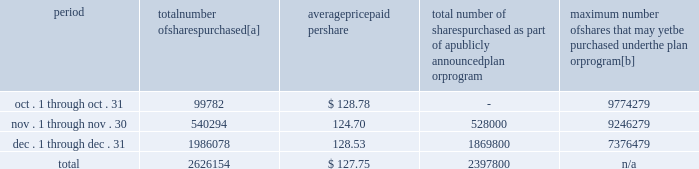Five-year performance comparison 2013 the following graph provides an indicator of cumulative total shareholder returns for the corporation as compared to the peer group index ( described above ) , the dow jones , and the s&p 500 .
The graph assumes that the value of the investment in the common stock of union pacific corporation and each index was $ 100 on december 31 , 2002 , and that all dividends were reinvested .
Comparison of five-year cumulative return 2002 2003 2004 2005 2006 2007 upc s&p 500 peer group dj trans purchases of equity securities 2013 during 2007 , we repurchased 13266070 shares of our common stock at an average price of $ 115.66 .
During the first nine months of 2007 , we repurchased 10639916 shares of our common stock at an average price per share of $ 112.68 .
The table presents common stock repurchases during each month for the fourth quarter of 2007 : period number of shares purchased average paid per total number of shares purchased as part of a publicly announced plan or program maximum number of shares that may yet be purchased under the plan or program .
[a] total number of shares purchased during the quarter includes 228354 shares delivered or attested to upc by employees to pay stock option exercise prices , satisfy excess tax withholding obligations for stock option exercises or vesting of retention units , and pay withholding obligations for vesting of retention shares .
[b] on january 30 , 2007 , our board of directors authorized us to repurchase up to 20 million shares of our common stock through december 31 , 2009 .
We may make these repurchases on the open market or through other transactions .
Our management has sole discretion with respect to determining the timing and amount of these transactions. .
What the percent of the total number of shares purchased in the fourth quarter of 2007 that was attested to upc by employees to pay stock option exercise prices? 
Computations: (228354 / 2626154)
Answer: 0.08695. Five-year performance comparison 2013 the following graph provides an indicator of cumulative total shareholder returns for the corporation as compared to the peer group index ( described above ) , the dow jones , and the s&p 500 .
The graph assumes that the value of the investment in the common stock of union pacific corporation and each index was $ 100 on december 31 , 2002 , and that all dividends were reinvested .
Comparison of five-year cumulative return 2002 2003 2004 2005 2006 2007 upc s&p 500 peer group dj trans purchases of equity securities 2013 during 2007 , we repurchased 13266070 shares of our common stock at an average price of $ 115.66 .
During the first nine months of 2007 , we repurchased 10639916 shares of our common stock at an average price per share of $ 112.68 .
The table presents common stock repurchases during each month for the fourth quarter of 2007 : period number of shares purchased average paid per total number of shares purchased as part of a publicly announced plan or program maximum number of shares that may yet be purchased under the plan or program .
[a] total number of shares purchased during the quarter includes 228354 shares delivered or attested to upc by employees to pay stock option exercise prices , satisfy excess tax withholding obligations for stock option exercises or vesting of retention units , and pay withholding obligations for vesting of retention shares .
[b] on january 30 , 2007 , our board of directors authorized us to repurchase up to 20 million shares of our common stock through december 31 , 2009 .
We may make these repurchases on the open market or through other transactions .
Our management has sole discretion with respect to determining the timing and amount of these transactions. .
During the fourth quarter of 2007 what was the percent of the total number of shares purchased in november? 
Computations: (540294 / 2626154)
Answer: 0.20574. 